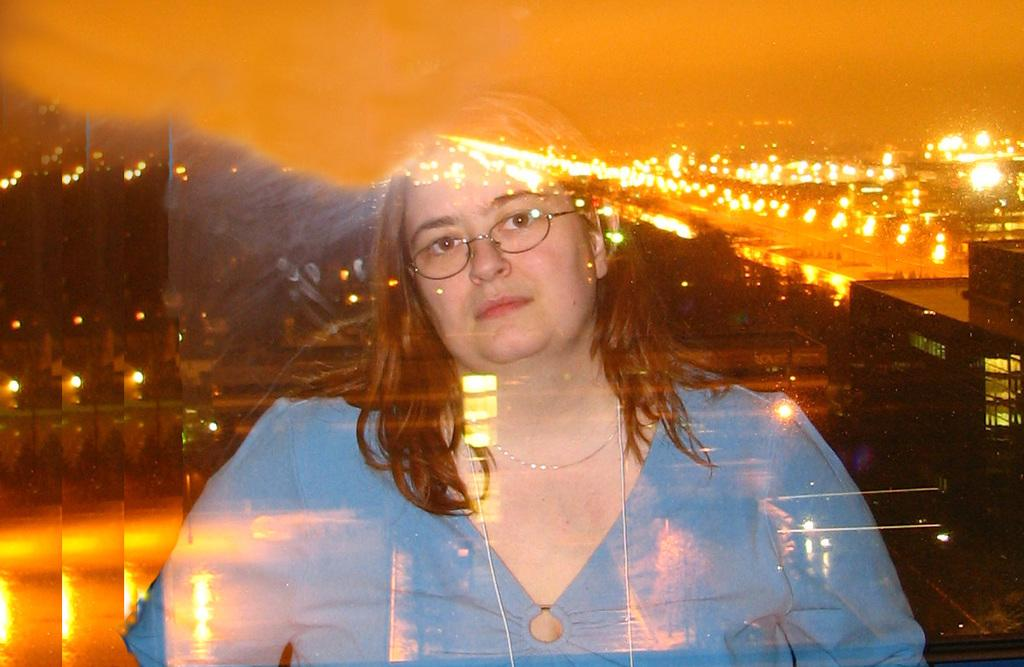Who is present in the image? There is a woman in the image. What can be seen in the background of the image? There is a building, a road, and light visible in the background of the image. Can you describe the setting of the image? The image features a woman in the foreground and a background with a building, road, and light. Is there any indication that the image has been altered? The image may have been edited. What type of sack is being carried by the giants in the image? There are no giants present in the image, and therefore no sacks are being carried. 